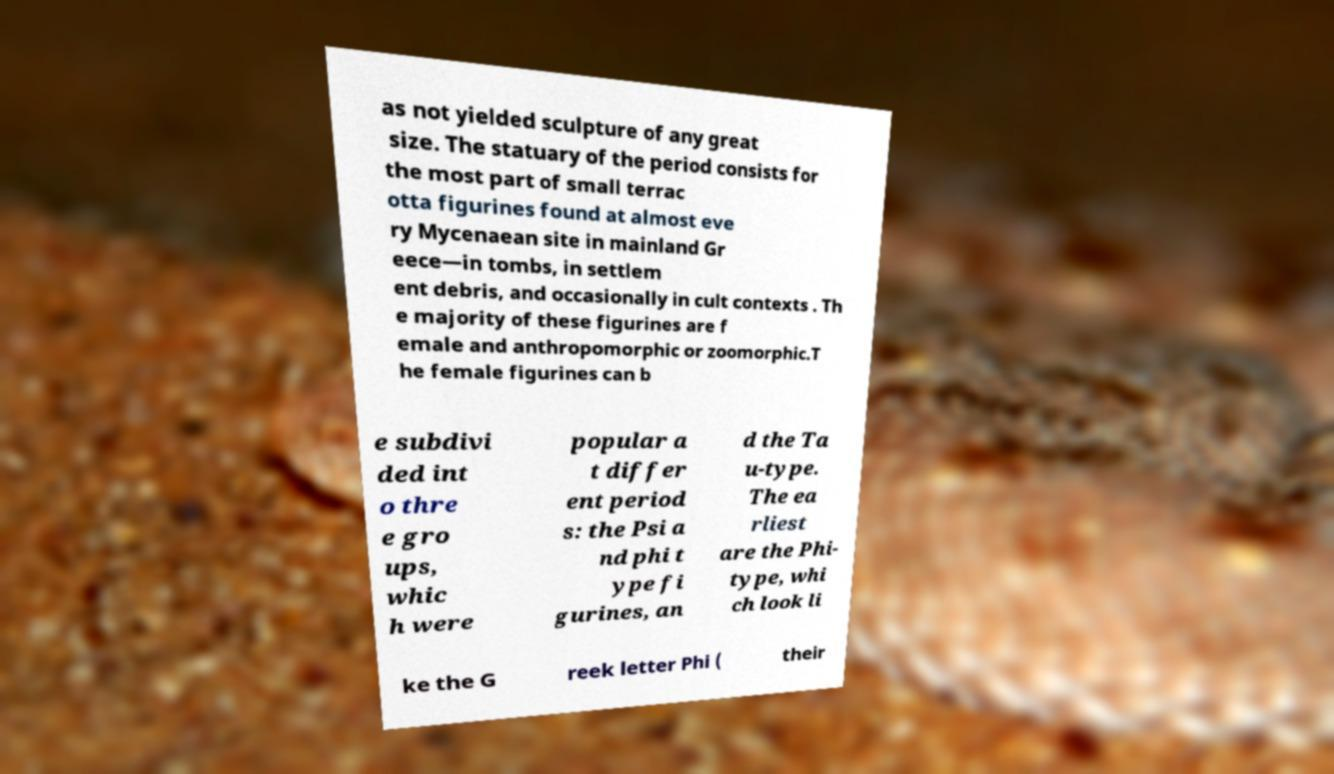Could you extract and type out the text from this image? as not yielded sculpture of any great size. The statuary of the period consists for the most part of small terrac otta figurines found at almost eve ry Mycenaean site in mainland Gr eece—in tombs, in settlem ent debris, and occasionally in cult contexts . Th e majority of these figurines are f emale and anthropomorphic or zoomorphic.T he female figurines can b e subdivi ded int o thre e gro ups, whic h were popular a t differ ent period s: the Psi a nd phi t ype fi gurines, an d the Ta u-type. The ea rliest are the Phi- type, whi ch look li ke the G reek letter Phi ( their 